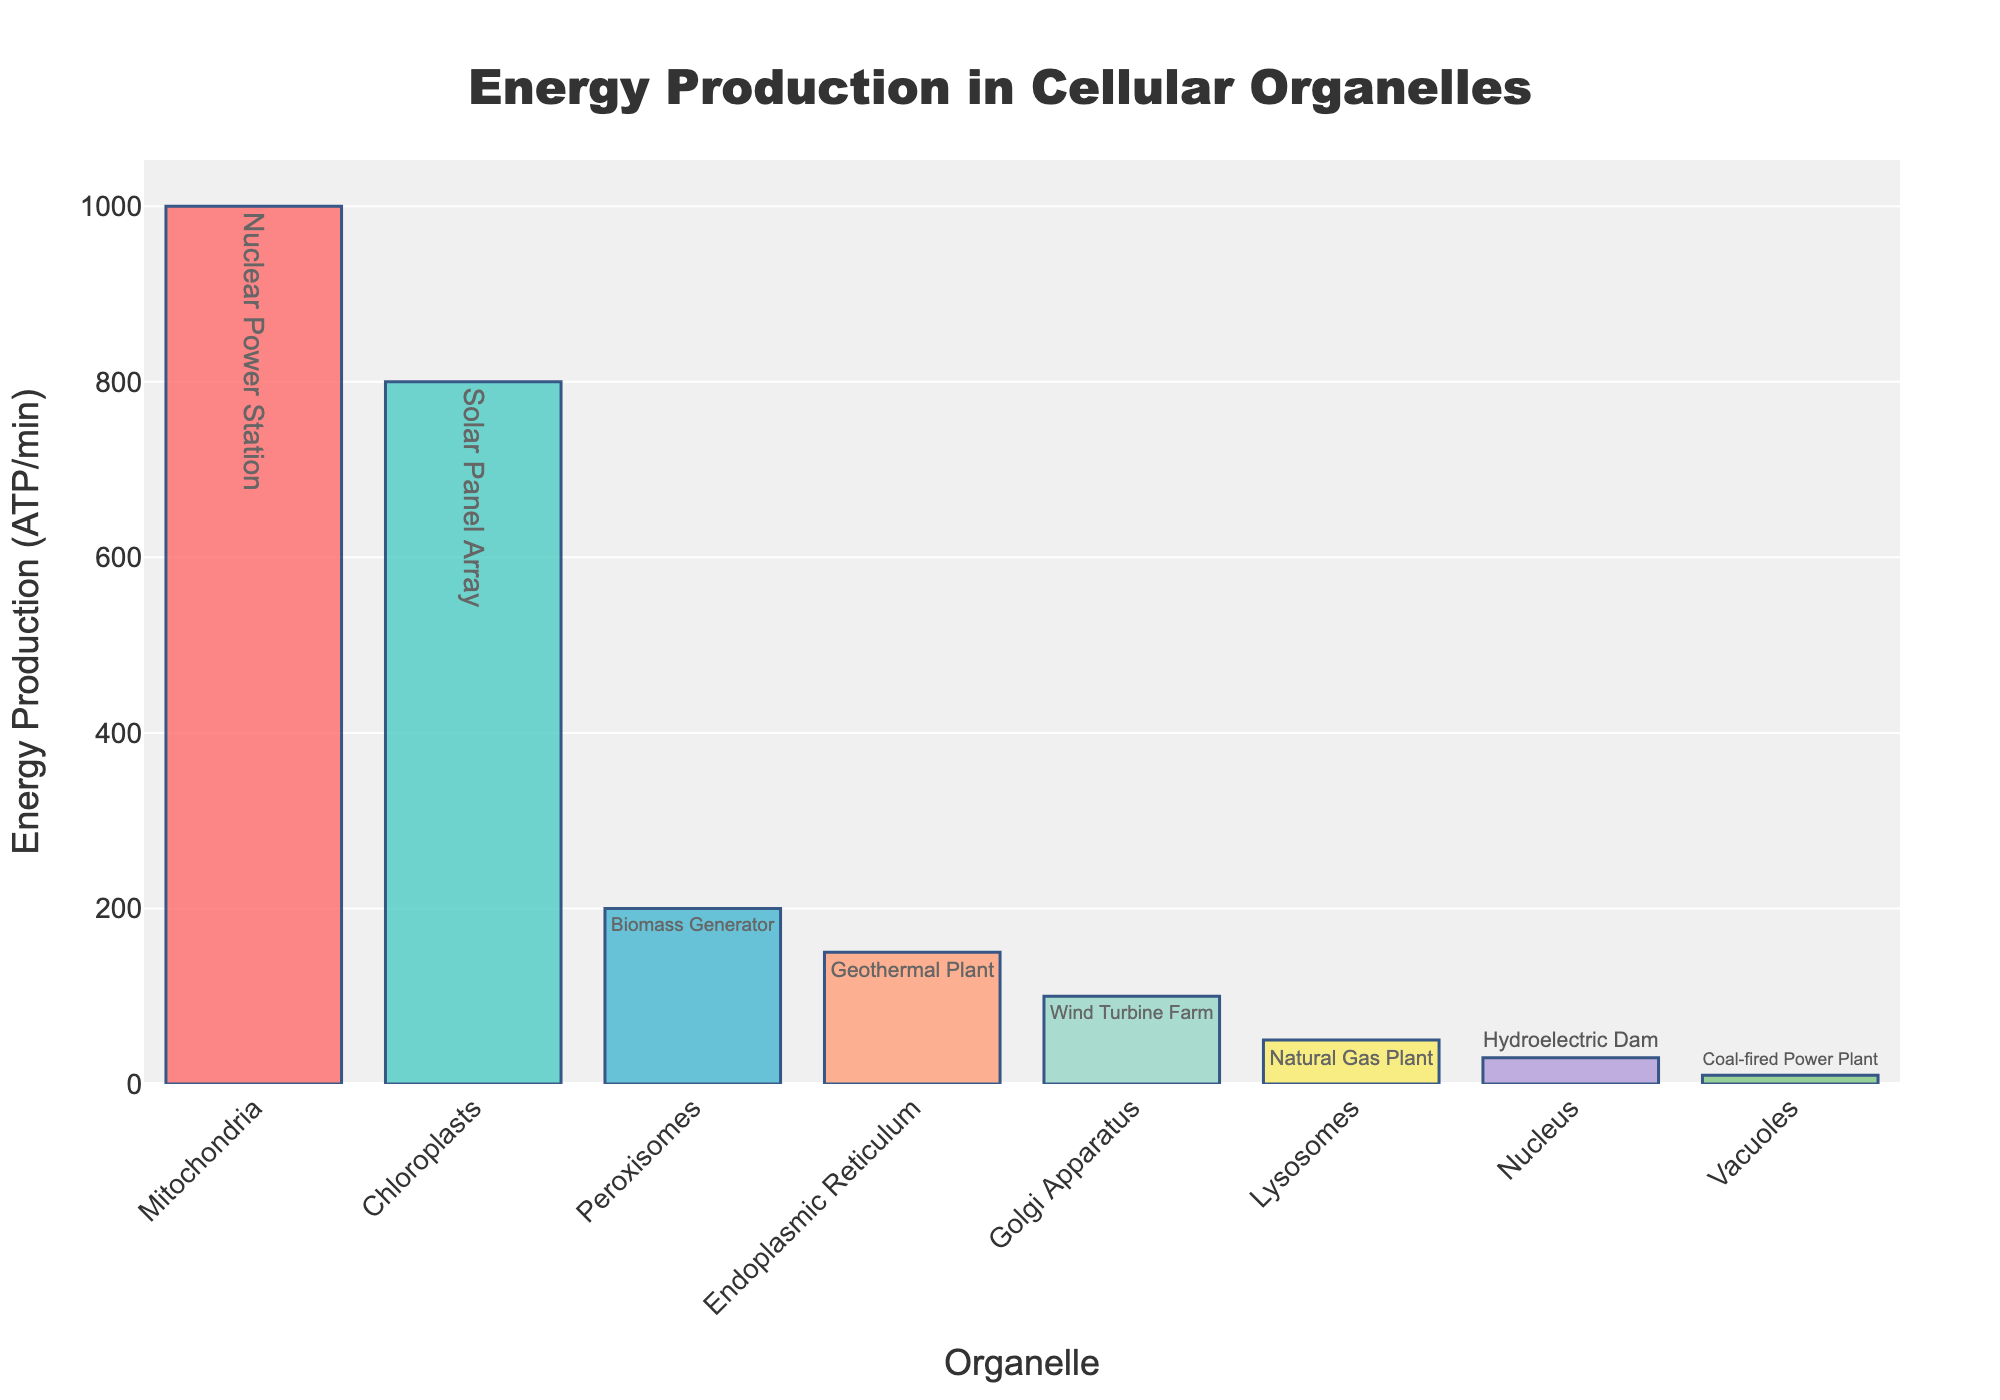Which organelle has the highest energy production? By looking at the height of the bars on the chart, the mitochondria have the highest bar, indicating the highest energy production.
Answer: Mitochondria How does the energy production of peroxisomes compare to that of the endoplasmic reticulum? The bar for peroxisomes reaches 200 ATP/min, while the bar for the endoplasmic reticulum reaches 150 ATP/min, indicating that peroxisomes produce more energy.
Answer: Peroxisomes produce more energy than the endoplasmic reticulum What is the total energy production of the top three organelles? The top three organelles are mitochondria, chloroplasts, and peroxisomes with energy productions of 1000, 800, and 200 ATP/min respectively. Summing these values: 1000 + 800 + 200 = 2000 ATP/min.
Answer: 2000 ATP/min Which organelle produces energy equivalent to a Wind Turbine Farm? By looking at the text labels, the Golgi apparatus is labeled with "Wind Turbine Farm."
Answer: Golgi Apparatus What is the difference in energy production between the nucleus and vacuoles? The energy production for the nucleus is 30 ATP/min, while for vacuoles it is 10 ATP/min. The difference is 30 - 10 = 20 ATP/min.
Answer: 20 ATP/min Which two organelles produce the least energy and what are their power plant equivalents? The two shortest bars belong to vacuoles and the nucleus, with energy productions of 10 and 30 ATP/min respectively. Their equivalents are Coal-fired Power Plant and Hydroelectric Dam.
Answer: Vacuoles (Coal-fired Power Plant) and Nucleus (Hydroelectric Dam) What is the average energy production of all the organelles? Sum the energy production values for all organelles (1000 + 800 + 200 + 150 + 100 + 50 + 30 + 10 = 2340), then divide by the number of organelles (8): 2340/8 = 292.5 ATP/min.
Answer: 292.5 ATP/min Which organelle equates to a Biomass Generator and what is its energy production level? The text label for peroxisomes indicates "Biomass Generator" and its bar reaches 200 ATP/min.
Answer: Peroxisomes, 200 ATP/min If you combine the energy production of the two least efficient organelles, does it exceed the energy produced by chloroplasts? The nucleus and vacuoles produce 30 and 10 ATP/min respectively. Their combined production is 30 + 10 = 40 ATP/min, which is less than the 800 ATP/min produced by chloroplasts.
Answer: No What color represents the energy production of the mitochondria? The bar for mitochondria is the tallest bar and is visually colored red.
Answer: Red 